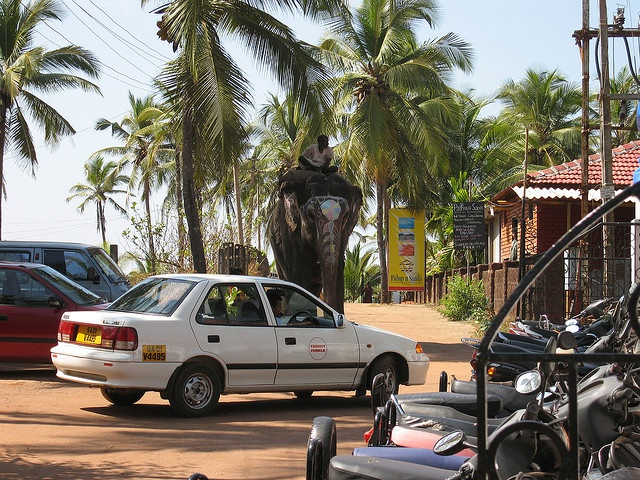Describe the objects in this image and their specific colors. I can see car in lightblue, darkgray, black, gray, and white tones, motorcycle in lightblue, black, darkgray, gray, and lightgray tones, elephant in lightblue, black, and gray tones, car in lightblue, black, maroon, blue, and gray tones, and motorcycle in lightblue, black, gray, white, and darkgray tones in this image. 